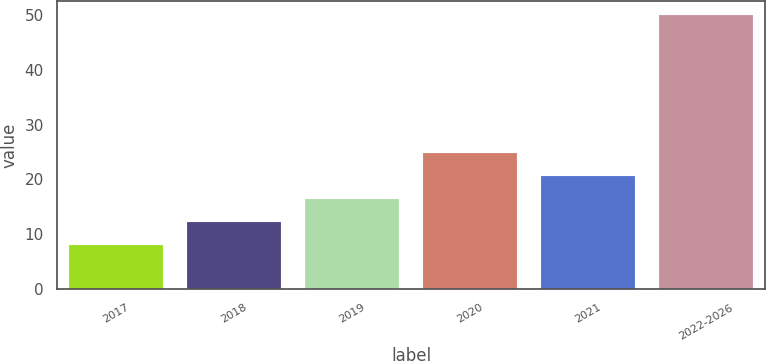Convert chart. <chart><loc_0><loc_0><loc_500><loc_500><bar_chart><fcel>2017<fcel>2018<fcel>2019<fcel>2020<fcel>2021<fcel>2022-2026<nl><fcel>8<fcel>12.2<fcel>16.4<fcel>24.8<fcel>20.6<fcel>50<nl></chart> 